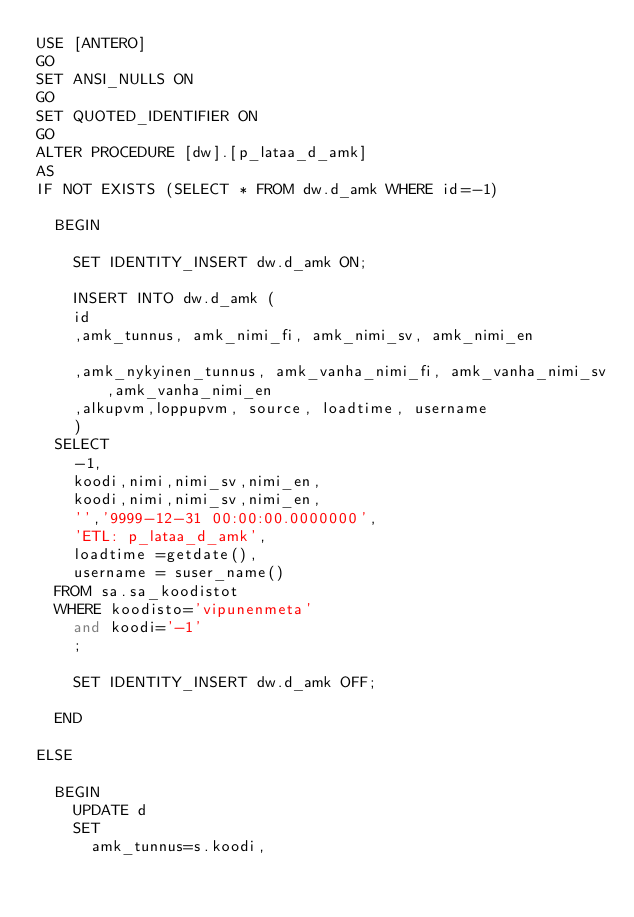<code> <loc_0><loc_0><loc_500><loc_500><_SQL_>USE [ANTERO]
GO
SET ANSI_NULLS ON
GO
SET QUOTED_IDENTIFIER ON
GO
ALTER PROCEDURE [dw].[p_lataa_d_amk]
AS
IF NOT EXISTS (SELECT * FROM dw.d_amk WHERE id=-1)

	BEGIN

	  SET IDENTITY_INSERT dw.d_amk ON;

	  INSERT INTO dw.d_amk (
		id
		,amk_tunnus, amk_nimi_fi, amk_nimi_sv, amk_nimi_en

		,amk_nykyinen_tunnus, amk_vanha_nimi_fi, amk_vanha_nimi_sv,amk_vanha_nimi_en
		,alkupvm,loppupvm, source, loadtime, username
	  )
	SELECT
		-1,
		koodi,nimi,nimi_sv,nimi_en,
		koodi,nimi,nimi_sv,nimi_en,
		'','9999-12-31 00:00:00.0000000',
		'ETL: p_lataa_d_amk',
		loadtime =getdate(),
		username = suser_name()
	FROM sa.sa_koodistot
	WHERE koodisto='vipunenmeta'
	  and koodi='-1'
	  ;

	  SET IDENTITY_INSERT dw.d_amk OFF;

	END

ELSE

	BEGIN
		UPDATE d
		SET
			amk_tunnus=s.koodi,</code> 